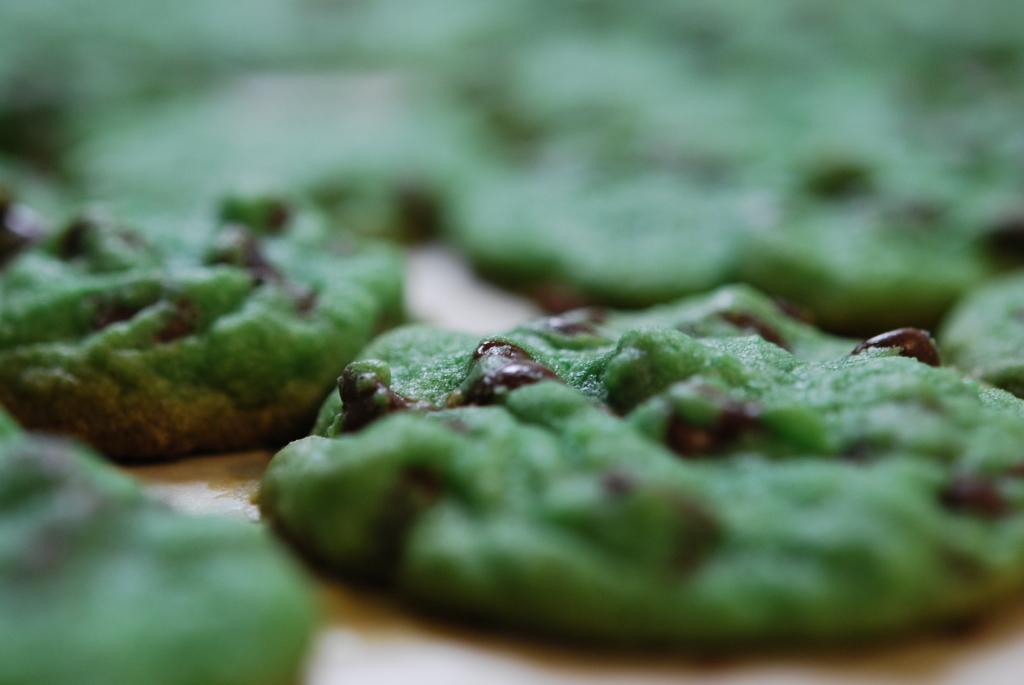In one or two sentences, can you explain what this image depicts? In this picture we can see a few food items on a wooden surface. Background is blurry. 